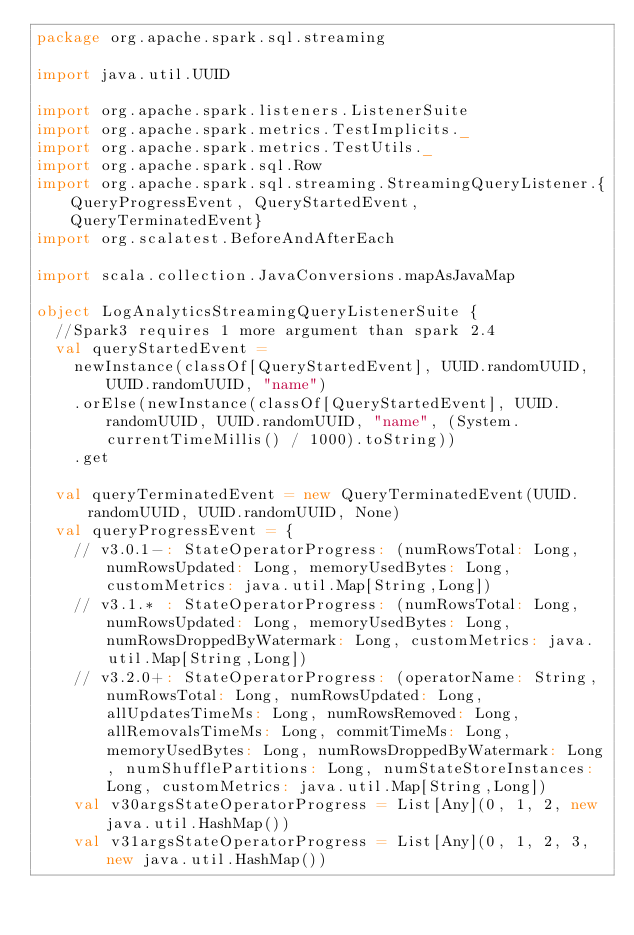<code> <loc_0><loc_0><loc_500><loc_500><_Scala_>package org.apache.spark.sql.streaming

import java.util.UUID

import org.apache.spark.listeners.ListenerSuite
import org.apache.spark.metrics.TestImplicits._
import org.apache.spark.metrics.TestUtils._
import org.apache.spark.sql.Row
import org.apache.spark.sql.streaming.StreamingQueryListener.{QueryProgressEvent, QueryStartedEvent, QueryTerminatedEvent}
import org.scalatest.BeforeAndAfterEach

import scala.collection.JavaConversions.mapAsJavaMap

object LogAnalyticsStreamingQueryListenerSuite {
  //Spark3 requires 1 more argument than spark 2.4
  val queryStartedEvent =
    newInstance(classOf[QueryStartedEvent], UUID.randomUUID, UUID.randomUUID, "name")
    .orElse(newInstance(classOf[QueryStartedEvent], UUID.randomUUID, UUID.randomUUID, "name", (System.currentTimeMillis() / 1000).toString))
    .get

  val queryTerminatedEvent = new QueryTerminatedEvent(UUID.randomUUID, UUID.randomUUID, None)
  val queryProgressEvent = {
    // v3.0.1-: StateOperatorProgress: (numRowsTotal: Long, numRowsUpdated: Long, memoryUsedBytes: Long, customMetrics: java.util.Map[String,Long])
    // v3.1.* : StateOperatorProgress: (numRowsTotal: Long, numRowsUpdated: Long, memoryUsedBytes: Long, numRowsDroppedByWatermark: Long, customMetrics: java.util.Map[String,Long])
    // v3.2.0+: StateOperatorProgress: (operatorName: String, numRowsTotal: Long, numRowsUpdated: Long, allUpdatesTimeMs: Long, numRowsRemoved: Long, allRemovalsTimeMs: Long, commitTimeMs: Long, memoryUsedBytes: Long, numRowsDroppedByWatermark: Long, numShufflePartitions: Long, numStateStoreInstances: Long, customMetrics: java.util.Map[String,Long])
    val v30argsStateOperatorProgress = List[Any](0, 1, 2, new java.util.HashMap())
    val v31argsStateOperatorProgress = List[Any](0, 1, 2, 3, new java.util.HashMap())</code> 